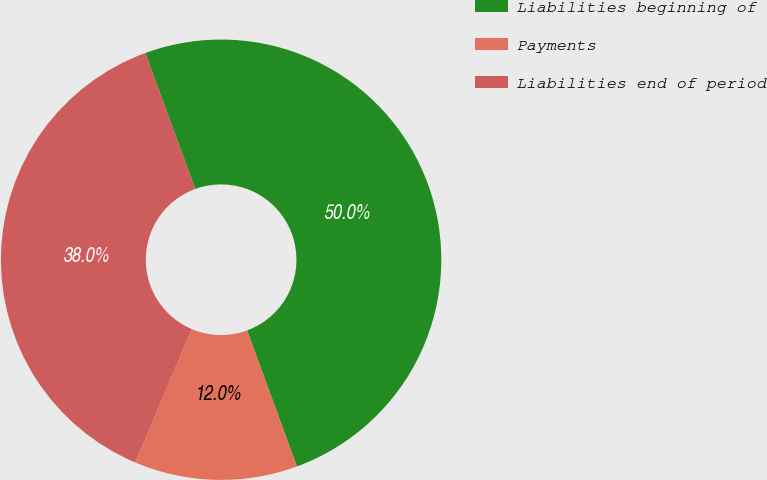Convert chart. <chart><loc_0><loc_0><loc_500><loc_500><pie_chart><fcel>Liabilities beginning of<fcel>Payments<fcel>Liabilities end of period<nl><fcel>50.0%<fcel>11.97%<fcel>38.03%<nl></chart> 